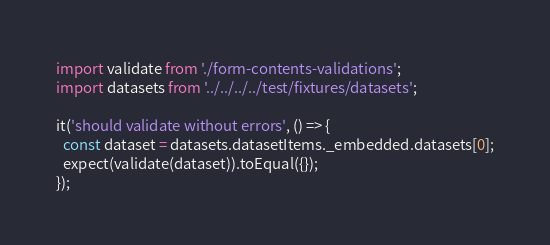<code> <loc_0><loc_0><loc_500><loc_500><_JavaScript_>import validate from './form-contents-validations';
import datasets from '../../../../test/fixtures/datasets';

it('should validate without errors', () => {
  const dataset = datasets.datasetItems._embedded.datasets[0];
  expect(validate(dataset)).toEqual({});
});
</code> 